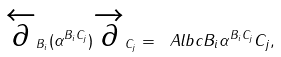<formula> <loc_0><loc_0><loc_500><loc_500>\overleftarrow { \partial } _ { B _ { i } } ( \alpha ^ { B _ { i } C _ { j } } ) \overrightarrow { \partial } _ { C _ { j } } = \ A l b c { B _ { i } } { \alpha ^ { B _ { i } C _ { j } } } { C _ { j } } ,</formula> 